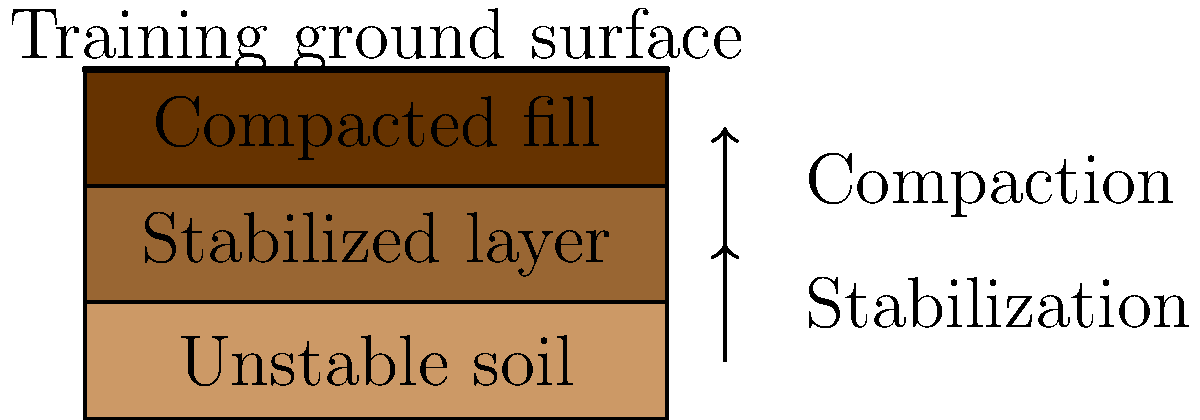As a supporter of G.D. Chaves, you're excited about the new training ground being constructed. However, the site has unstable soil conditions. Which soil stabilization technique would be most effective for improving the bearing capacity and reducing settlement of the unstable layer shown in the diagram, considering the need for a quick and cost-effective solution? To determine the most effective soil stabilization technique for the G.D. Chaves training ground, let's consider the following steps:

1. Analyze the soil conditions:
   The diagram shows an unstable soil layer at the bottom, which needs to be stabilized to support the training ground.

2. Consider the project requirements:
   - Quick implementation
   - Cost-effective solution
   - Improved bearing capacity
   - Reduced settlement

3. Evaluate potential stabilization techniques:
   a) Cement stabilization: Effective but can be expensive and time-consuming.
   b) Lime stabilization: Good for clay soils but may not be suitable for all soil types.
   c) Chemical grouting: Can be expensive and may have environmental concerns.
   d) Geotextile reinforcement: Quick to install but may not provide sufficient bearing capacity alone.
   e) Soil mixing: Effective for various soil types and can be implemented relatively quickly.

4. Choose the most suitable technique:
   Considering the need for a quick and cost-effective solution that improves bearing capacity and reduces settlement, soil mixing emerges as the most appropriate technique.

5. Justify the choice:
   - Soil mixing can be applied to various soil types.
   - It can be implemented relatively quickly compared to other methods.
   - It provides good improvement in bearing capacity and reduces settlement.
   - The cost is generally lower than extensive chemical treatments or deep foundation solutions.
   - It creates a uniform stabilized layer, as shown in the diagram.

6. Implementation:
   The soil mixing technique would be applied to the unstable layer, creating the stabilized layer shown in the diagram. This would be followed by the addition of a compacted fill layer to further improve the ground conditions for the training surface.
Answer: Soil mixing 